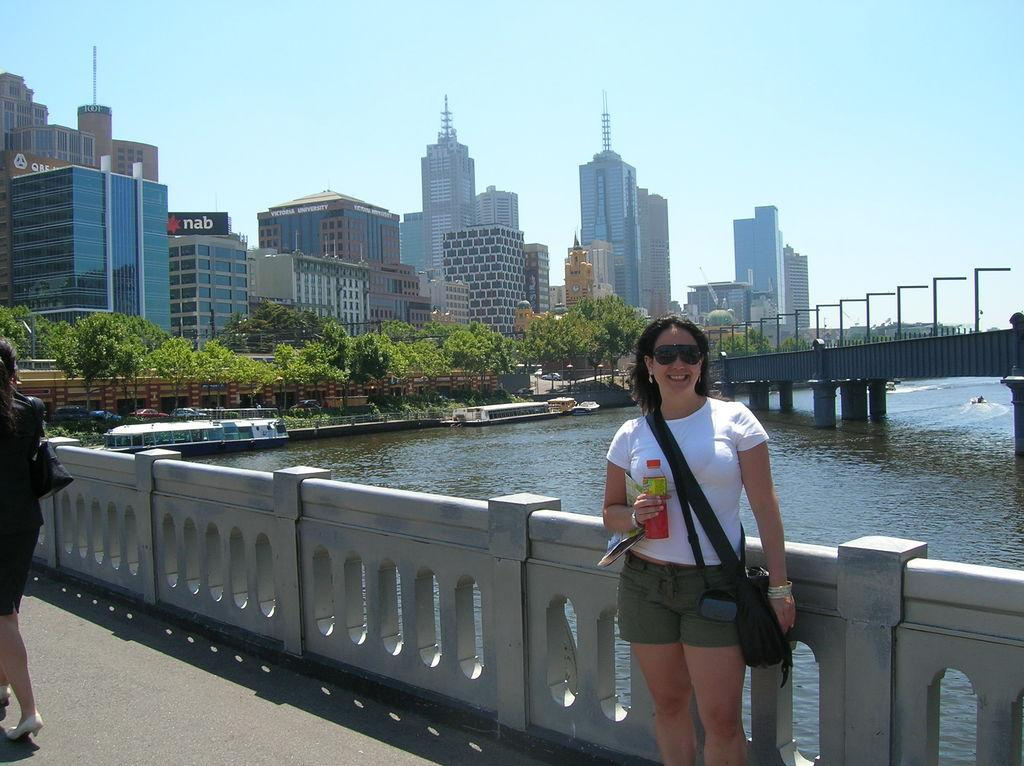What is the person in the image holding? The person is holding a bottle in the image. Where is the person standing? The person is standing on a bridge. What can be seen in the background of the image? There is a river, a boat, trees, buildings, lights, and the sky visible in the background of the image. What type of laborer is working on the bridge in the image? There is no laborer present in the image; it only shows a person holding a bottle while standing on a bridge. What kind of party is happening on the boat in the background of the image? There is no party happening on the boat in the background of the image; it is simply a boat visible in the river. 